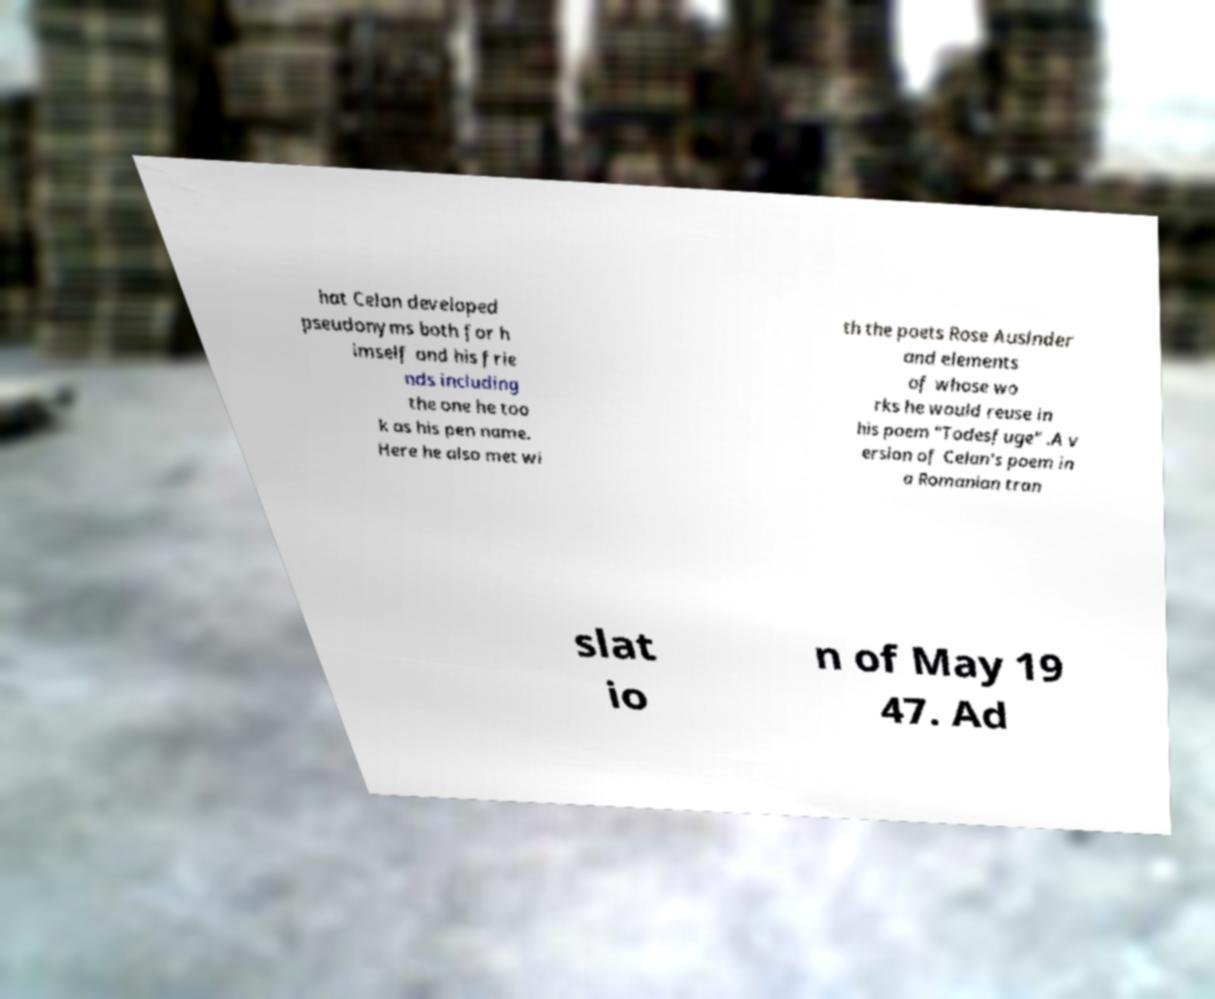I need the written content from this picture converted into text. Can you do that? hat Celan developed pseudonyms both for h imself and his frie nds including the one he too k as his pen name. Here he also met wi th the poets Rose Auslnder and elements of whose wo rks he would reuse in his poem "Todesfuge" .A v ersion of Celan's poem in a Romanian tran slat io n of May 19 47. Ad 